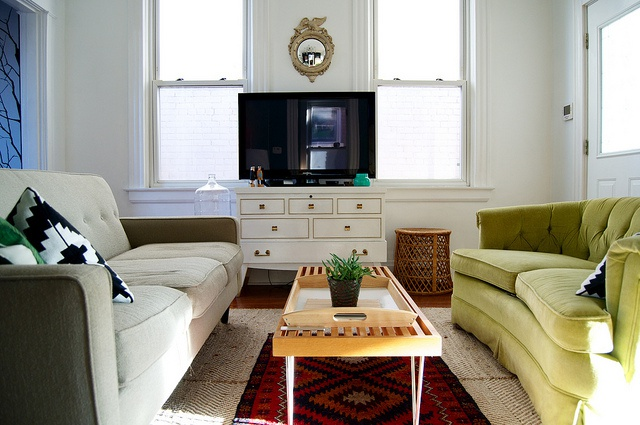Describe the objects in this image and their specific colors. I can see couch in black, darkgray, lightgray, and gray tones, couch in black, olive, white, and khaki tones, tv in black, navy, darkgray, and gray tones, potted plant in black, darkgreen, and darkgray tones, and clock in black, darkgray, and lightgray tones in this image. 